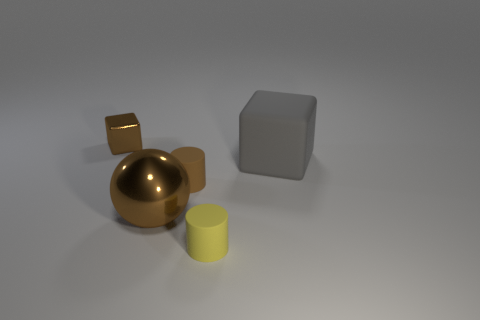Can you describe the lighting in the scene? The lighting in the scene appears to be soft and diffused, coming from an indirect source. It casts gentle shadows on the side of the objects opposite to the light source, suggesting it might be overhead or slightly to the front. The overall ambiance is calm and subdued, with no harsh shadows, giving the composition a studio-like quality. 